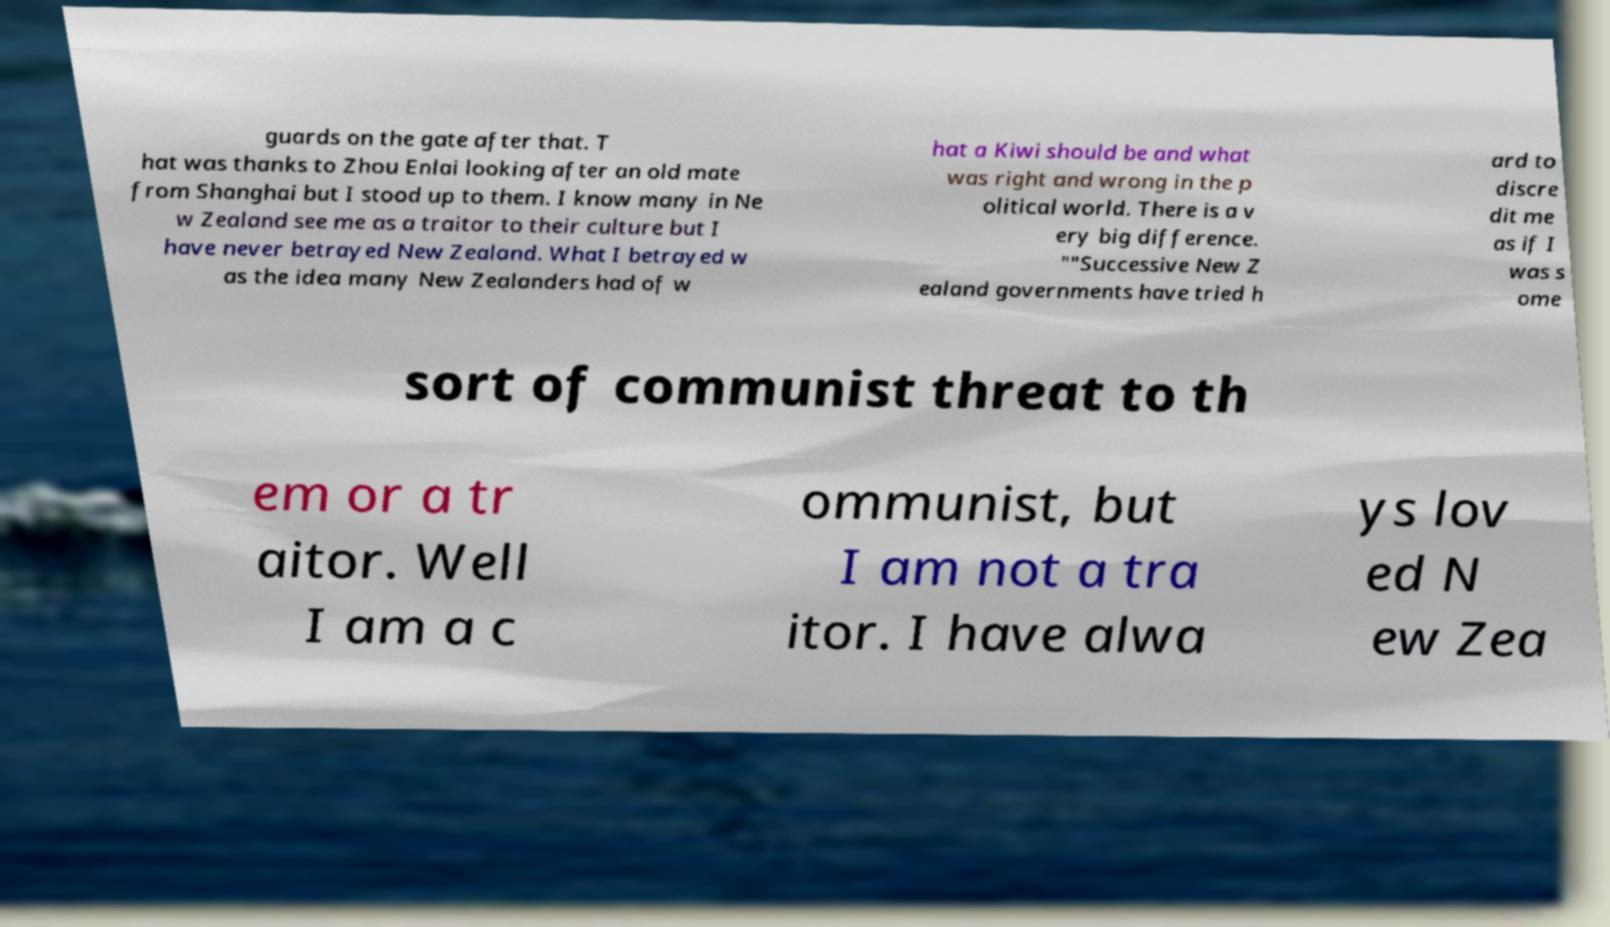Can you accurately transcribe the text from the provided image for me? guards on the gate after that. T hat was thanks to Zhou Enlai looking after an old mate from Shanghai but I stood up to them. I know many in Ne w Zealand see me as a traitor to their culture but I have never betrayed New Zealand. What I betrayed w as the idea many New Zealanders had of w hat a Kiwi should be and what was right and wrong in the p olitical world. There is a v ery big difference. ""Successive New Z ealand governments have tried h ard to discre dit me as if I was s ome sort of communist threat to th em or a tr aitor. Well I am a c ommunist, but I am not a tra itor. I have alwa ys lov ed N ew Zea 